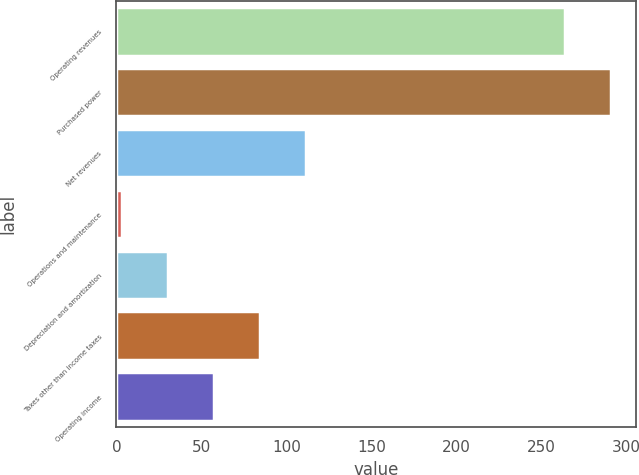<chart> <loc_0><loc_0><loc_500><loc_500><bar_chart><fcel>Operating revenues<fcel>Purchased power<fcel>Net revenues<fcel>Operations and maintenance<fcel>Depreciation and amortization<fcel>Taxes other than income taxes<fcel>Operating income<nl><fcel>264<fcel>291.1<fcel>111.4<fcel>3<fcel>30.1<fcel>84.3<fcel>57.2<nl></chart> 